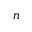Convert formula to latex. <formula><loc_0><loc_0><loc_500><loc_500>_ { n }</formula> 